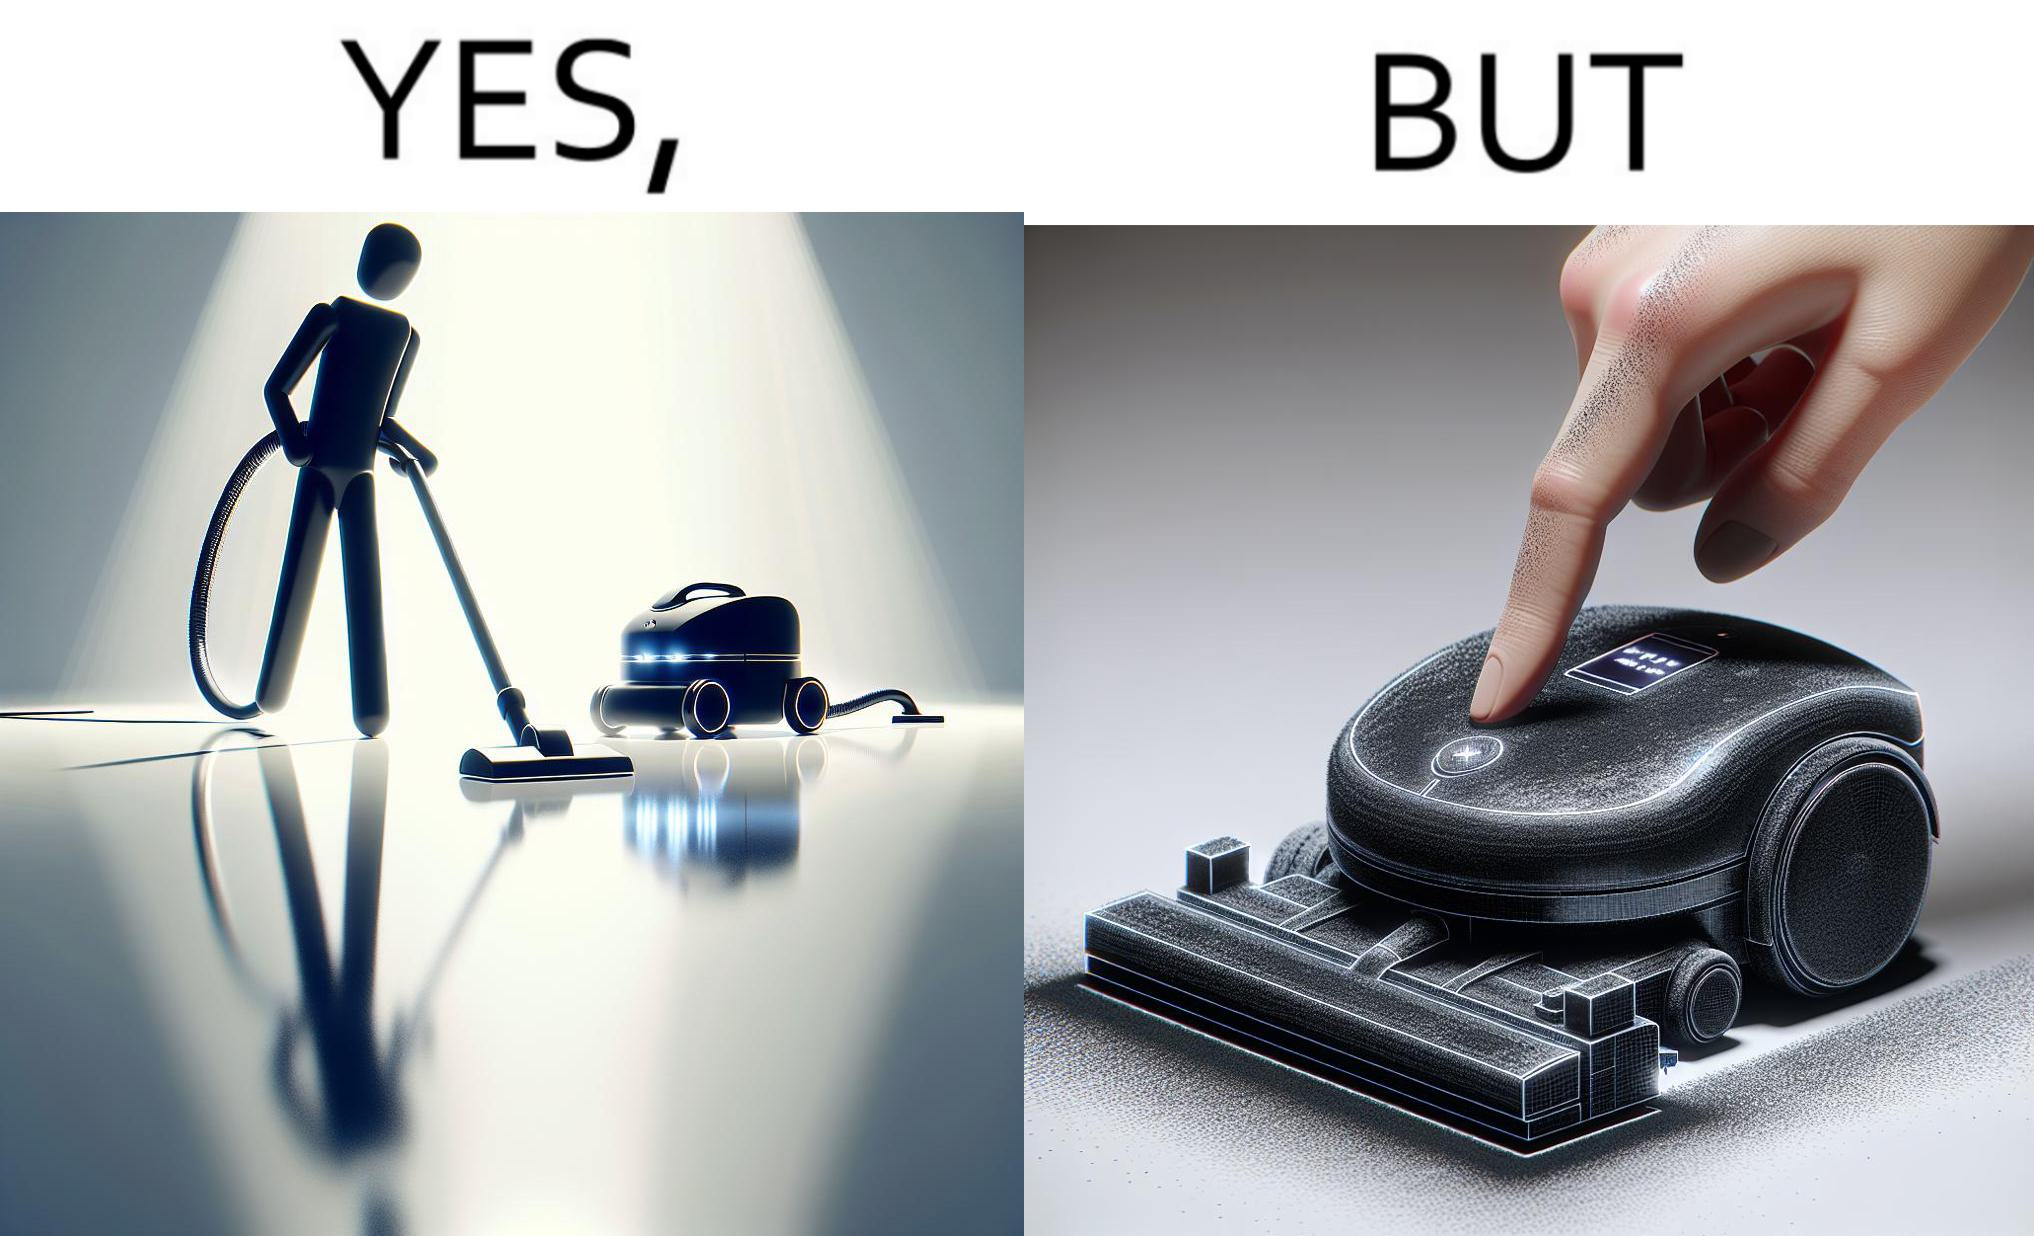Does this image contain satire or humor? Yes, this image is satirical. 